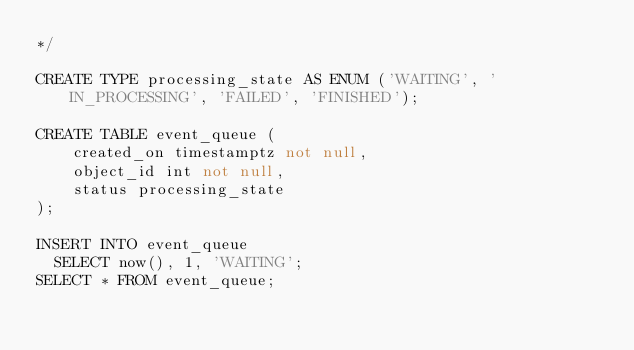<code> <loc_0><loc_0><loc_500><loc_500><_SQL_>*/

CREATE TYPE processing_state AS ENUM ('WAITING', 'IN_PROCESSING', 'FAILED', 'FINISHED');

CREATE TABLE event_queue (
    created_on timestamptz not null,
    object_id int not null,
    status processing_state
);

INSERT INTO event_queue
  SELECT now(), 1, 'WAITING';
SELECT * FROM event_queue;
</code> 